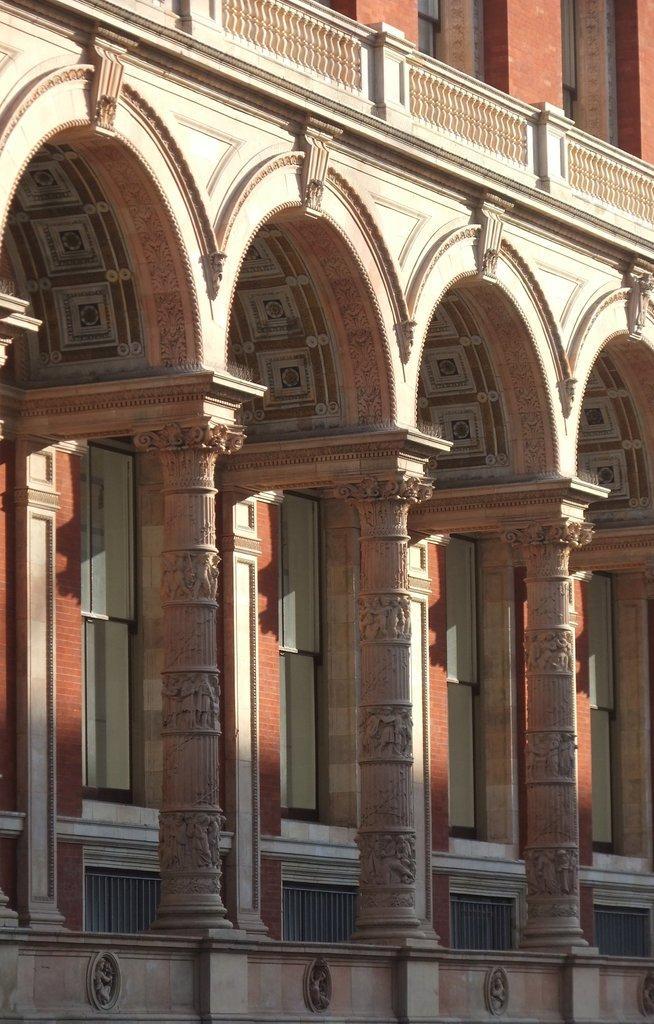Describe this image in one or two sentences. In this picture we can see a building, there are three pillars in the front. 